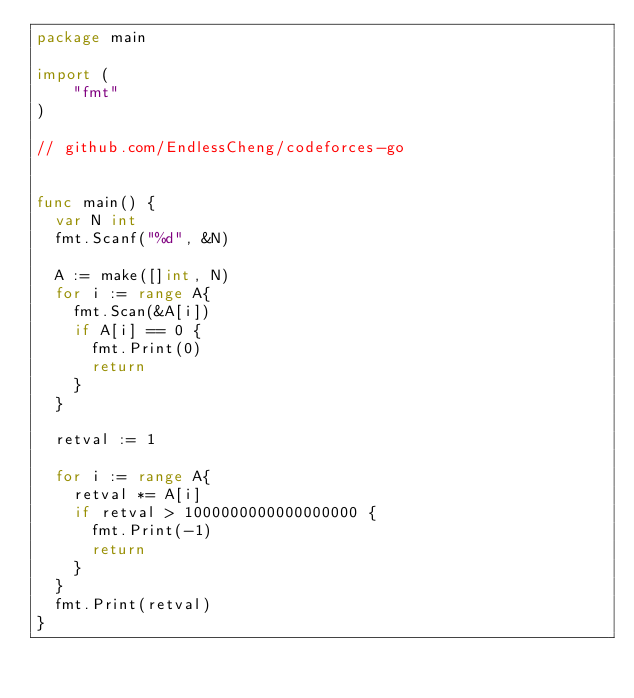<code> <loc_0><loc_0><loc_500><loc_500><_Go_>package main

import (
	"fmt"
)
 
// github.com/EndlessCheng/codeforces-go


func main() {
  var N int
  fmt.Scanf("%d", &N)

  A := make([]int, N)
  for i := range A{
    fmt.Scan(&A[i])
    if A[i] == 0 {
      fmt.Print(0)
      return
    }
  }  
  
  retval := 1
  
  for i := range A{
    retval *= A[i]
    if retval > 1000000000000000000 {
      fmt.Print(-1)
      return
    }
  }
  fmt.Print(retval)
}</code> 